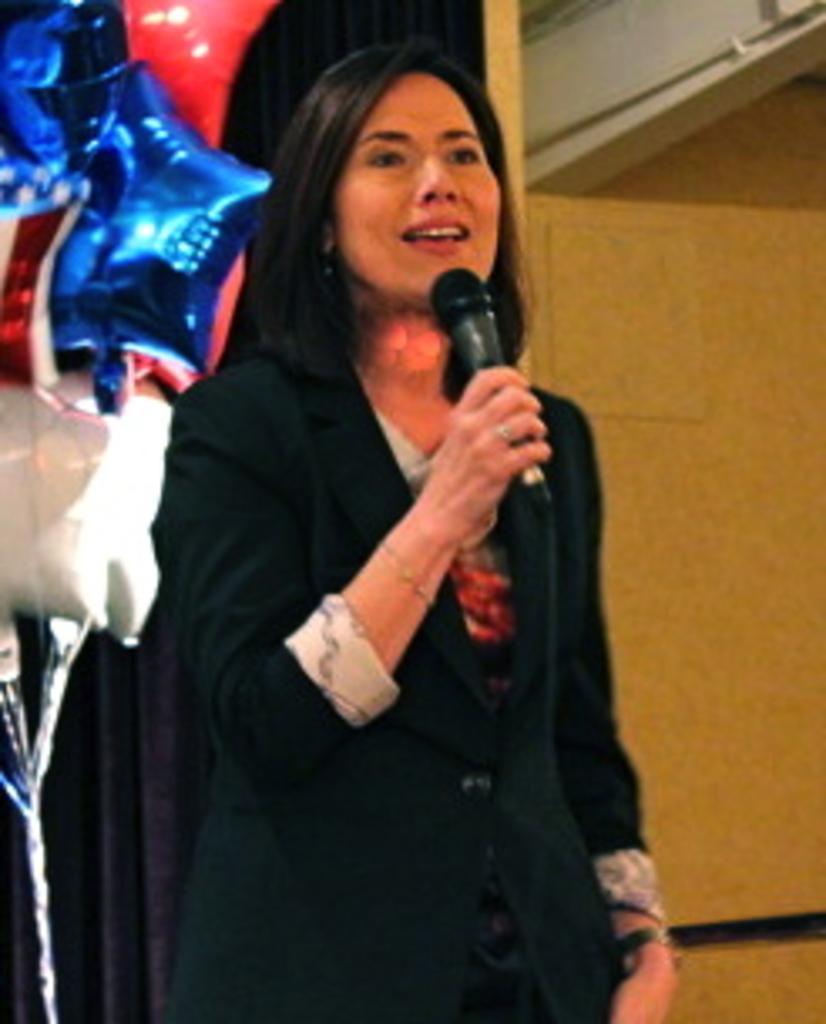Could you give a brief overview of what you see in this image? In this image, In the middle there is a woman standing and she is holding a microphone and she is speaking in the microphone and in the right side there is a yellow color wall and in the left side there are some blue color objects. 